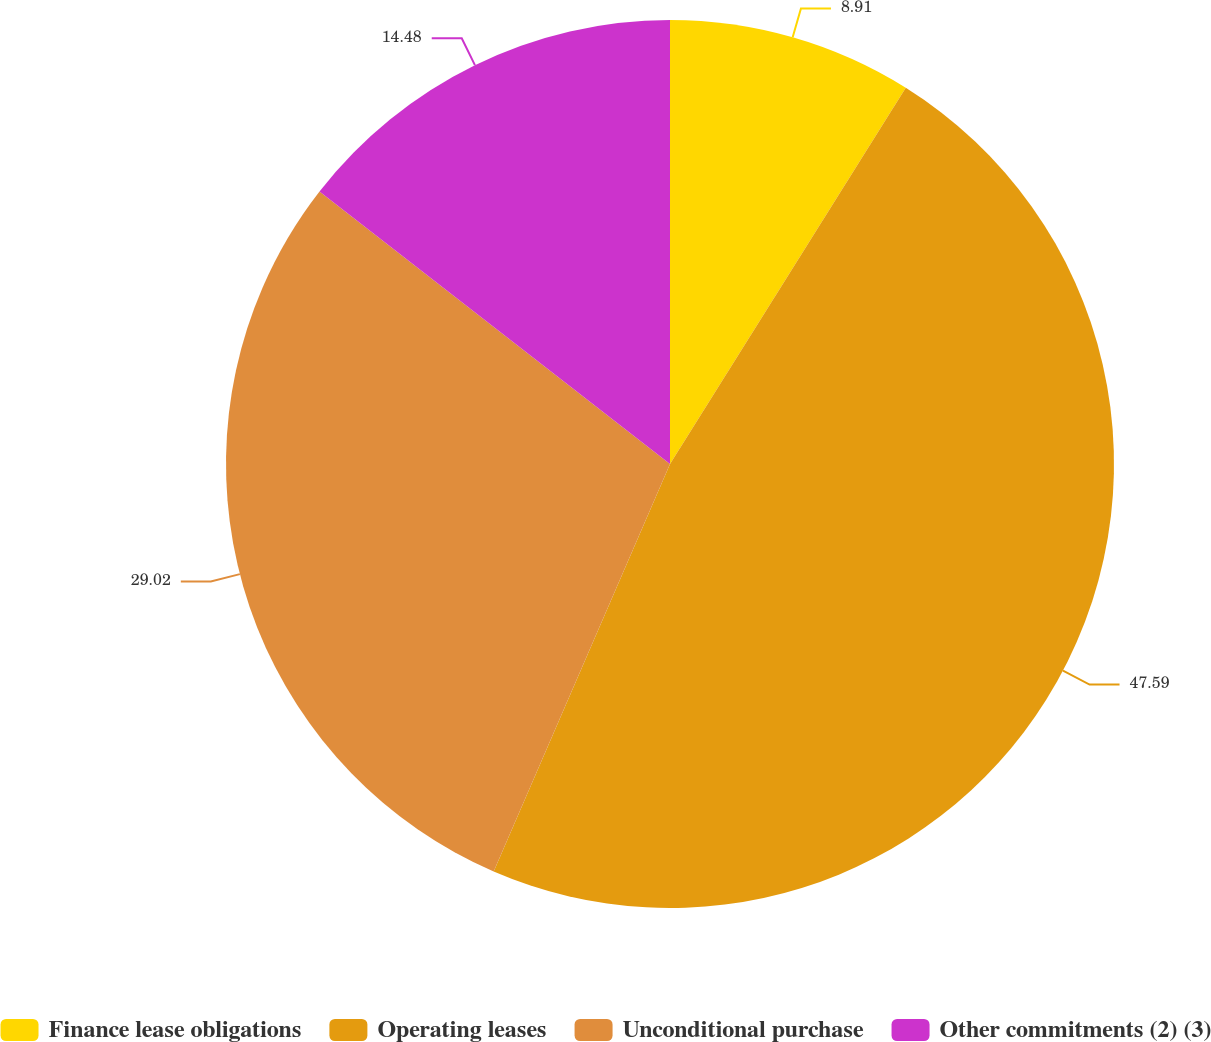<chart> <loc_0><loc_0><loc_500><loc_500><pie_chart><fcel>Finance lease obligations<fcel>Operating leases<fcel>Unconditional purchase<fcel>Other commitments (2) (3)<nl><fcel>8.91%<fcel>47.59%<fcel>29.02%<fcel>14.48%<nl></chart> 